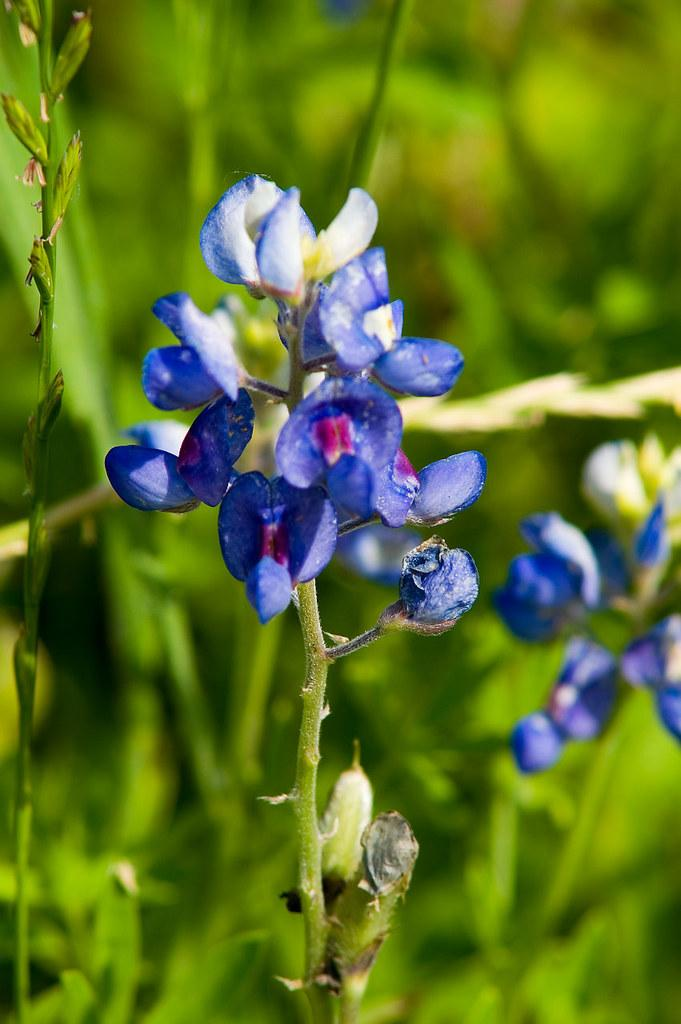What type of plant is visible in the image? There are flowers on a plant in the image. What else can be seen in the background of the image? There are leaves in the background of the image. How many rabbits can be seen playing on the coast in the image? There are no rabbits or coast visible in the image; it features a plant with flowers and leaves in the background. 